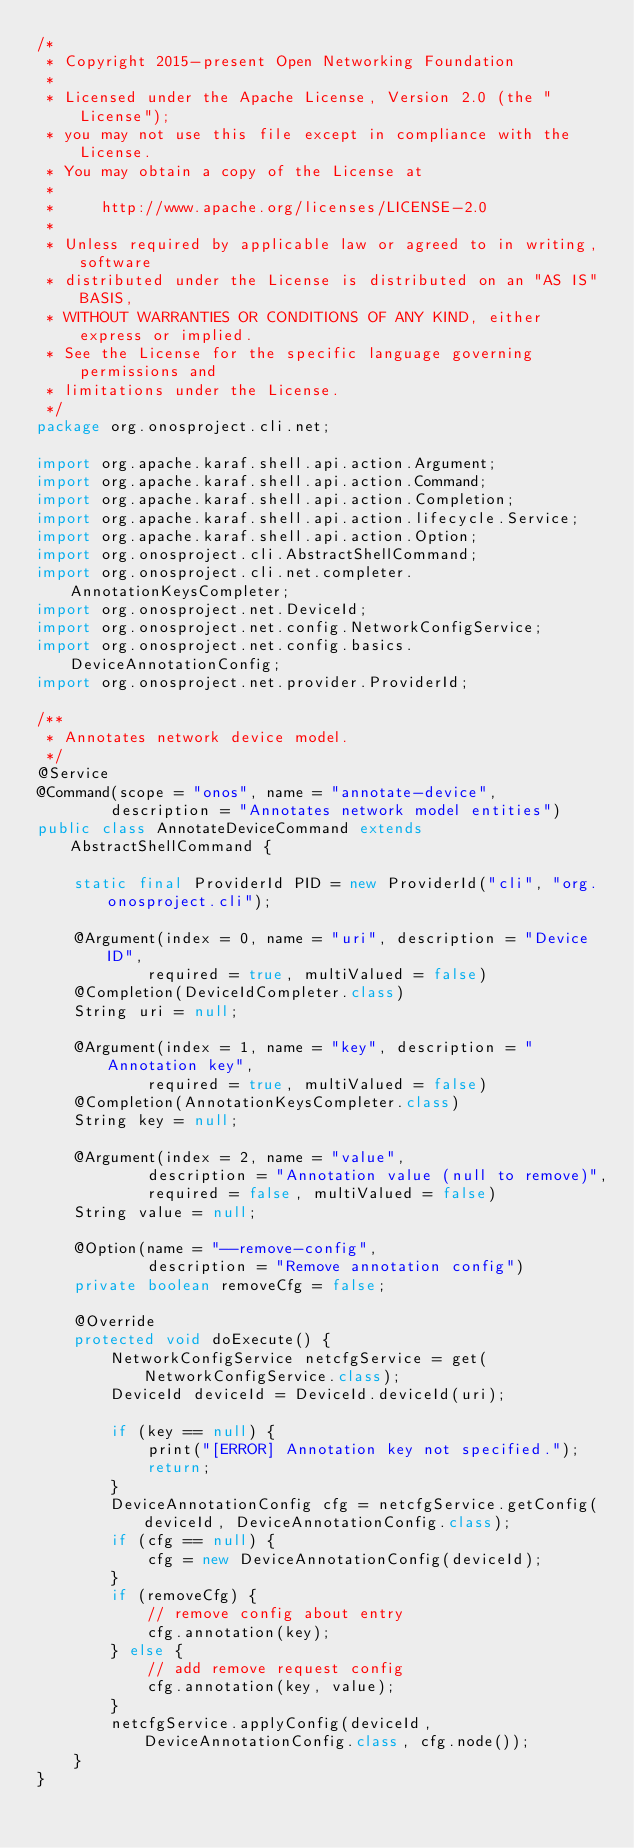<code> <loc_0><loc_0><loc_500><loc_500><_Java_>/*
 * Copyright 2015-present Open Networking Foundation
 *
 * Licensed under the Apache License, Version 2.0 (the "License");
 * you may not use this file except in compliance with the License.
 * You may obtain a copy of the License at
 *
 *     http://www.apache.org/licenses/LICENSE-2.0
 *
 * Unless required by applicable law or agreed to in writing, software
 * distributed under the License is distributed on an "AS IS" BASIS,
 * WITHOUT WARRANTIES OR CONDITIONS OF ANY KIND, either express or implied.
 * See the License for the specific language governing permissions and
 * limitations under the License.
 */
package org.onosproject.cli.net;

import org.apache.karaf.shell.api.action.Argument;
import org.apache.karaf.shell.api.action.Command;
import org.apache.karaf.shell.api.action.Completion;
import org.apache.karaf.shell.api.action.lifecycle.Service;
import org.apache.karaf.shell.api.action.Option;
import org.onosproject.cli.AbstractShellCommand;
import org.onosproject.cli.net.completer.AnnotationKeysCompleter;
import org.onosproject.net.DeviceId;
import org.onosproject.net.config.NetworkConfigService;
import org.onosproject.net.config.basics.DeviceAnnotationConfig;
import org.onosproject.net.provider.ProviderId;

/**
 * Annotates network device model.
 */
@Service
@Command(scope = "onos", name = "annotate-device",
        description = "Annotates network model entities")
public class AnnotateDeviceCommand extends AbstractShellCommand {

    static final ProviderId PID = new ProviderId("cli", "org.onosproject.cli");

    @Argument(index = 0, name = "uri", description = "Device ID",
            required = true, multiValued = false)
    @Completion(DeviceIdCompleter.class)
    String uri = null;

    @Argument(index = 1, name = "key", description = "Annotation key",
            required = true, multiValued = false)
    @Completion(AnnotationKeysCompleter.class)
    String key = null;

    @Argument(index = 2, name = "value",
            description = "Annotation value (null to remove)",
            required = false, multiValued = false)
    String value = null;

    @Option(name = "--remove-config",
            description = "Remove annotation config")
    private boolean removeCfg = false;

    @Override
    protected void doExecute() {
        NetworkConfigService netcfgService = get(NetworkConfigService.class);
        DeviceId deviceId = DeviceId.deviceId(uri);

        if (key == null) {
            print("[ERROR] Annotation key not specified.");
            return;
        }
        DeviceAnnotationConfig cfg = netcfgService.getConfig(deviceId, DeviceAnnotationConfig.class);
        if (cfg == null) {
            cfg = new DeviceAnnotationConfig(deviceId);
        }
        if (removeCfg) {
            // remove config about entry
            cfg.annotation(key);
        } else {
            // add remove request config
            cfg.annotation(key, value);
        }
        netcfgService.applyConfig(deviceId, DeviceAnnotationConfig.class, cfg.node());
    }
}
</code> 